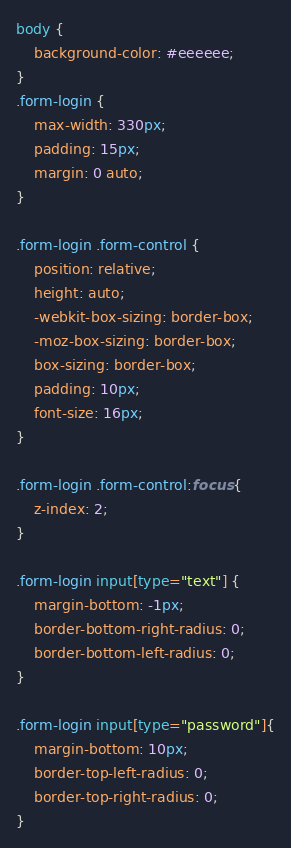Convert code to text. <code><loc_0><loc_0><loc_500><loc_500><_CSS_>body {
    background-color: #eeeeee;
}
.form-login {
    max-width: 330px;
    padding: 15px;
    margin: 0 auto;
}

.form-login .form-control {
    position: relative;
    height: auto;
    -webkit-box-sizing: border-box;
    -moz-box-sizing: border-box;
    box-sizing: border-box;
    padding: 10px;
    font-size: 16px;
}

.form-login .form-control:focus {
    z-index: 2;
}

.form-login input[type="text"] {
    margin-bottom: -1px;
    border-bottom-right-radius: 0;
    border-bottom-left-radius: 0;
}

.form-login input[type="password"]{
    margin-bottom: 10px;
    border-top-left-radius: 0;
    border-top-right-radius: 0;
}</code> 